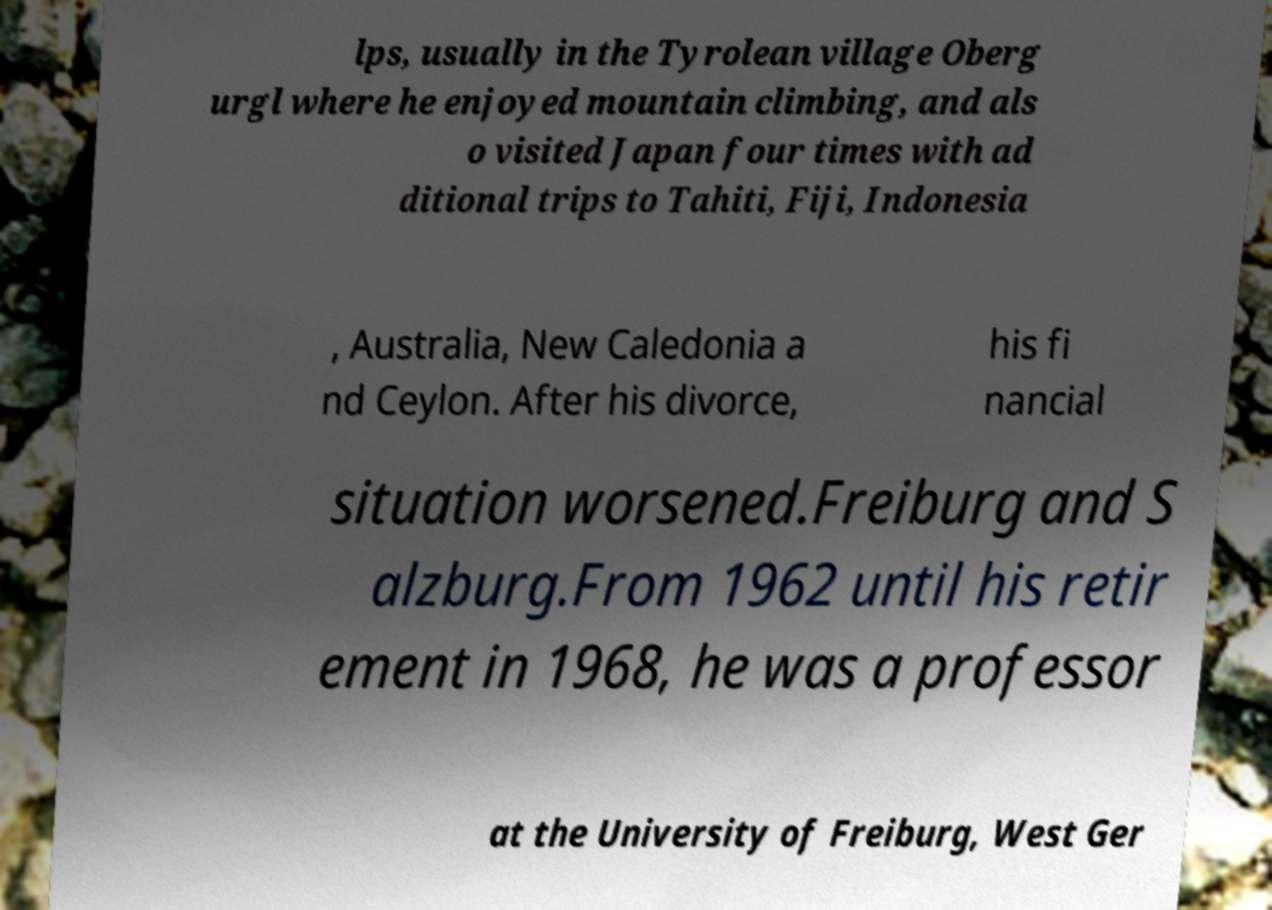For documentation purposes, I need the text within this image transcribed. Could you provide that? lps, usually in the Tyrolean village Oberg urgl where he enjoyed mountain climbing, and als o visited Japan four times with ad ditional trips to Tahiti, Fiji, Indonesia , Australia, New Caledonia a nd Ceylon. After his divorce, his fi nancial situation worsened.Freiburg and S alzburg.From 1962 until his retir ement in 1968, he was a professor at the University of Freiburg, West Ger 